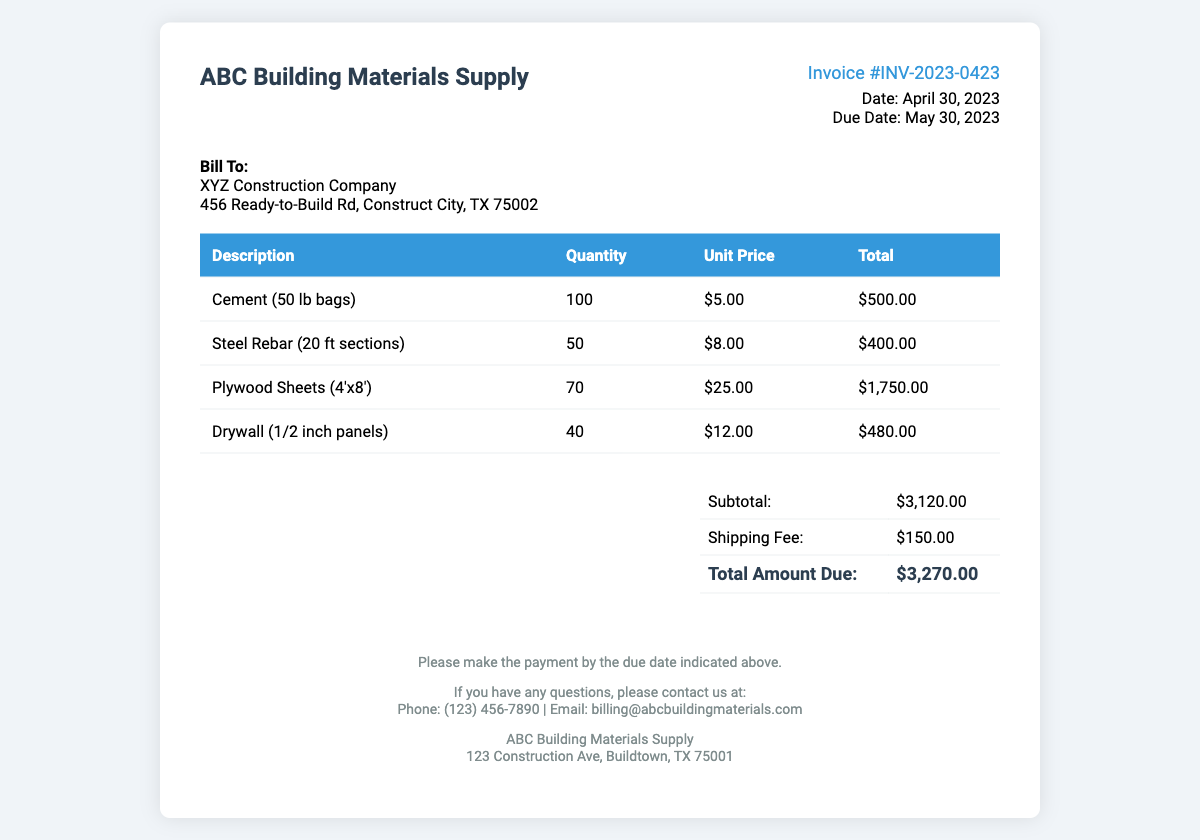What is the invoice number? The invoice number is a unique identifier for the transaction in the document, which is INV-2023-0423.
Answer: INV-2023-0423 What is the date of the invoice? The date of the invoice indicates when it was issued, which is April 30, 2023.
Answer: April 30, 2023 What is the total amount due? The total amount due is the final amount that needs to be paid, which is $3,270.00.
Answer: $3,270.00 How many sheets of plywood were purchased? The quantity of plywood sheets purchased is listed in the itemized costs, which is 70.
Answer: 70 What is the subtotal before shipping fees? The subtotal represents the total cost of all purchased materials before any additional fees, which is $3,120.00.
Answer: $3,120.00 What is the shipping fee? The shipping fee is specified as an additional charge for delivery, which is $150.00.
Answer: $150.00 Who is the bill to? The bill to indicates the recipient company for the invoice, which is XYZ Construction Company.
Answer: XYZ Construction Company What is the due date for payment? The due date indicates when the payment should be made, which is May 30, 2023.
Answer: May 30, 2023 What type of document is this? This document is categorized as an invoice, which is a request for payment for goods or services provided.
Answer: Invoice 